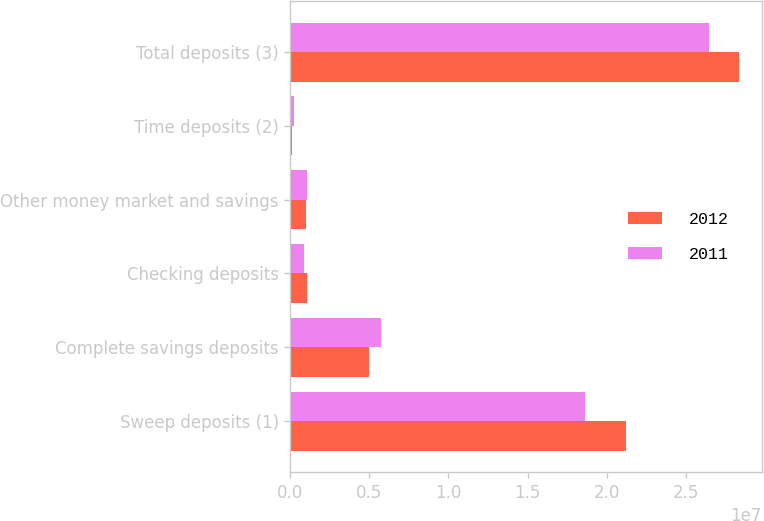<chart> <loc_0><loc_0><loc_500><loc_500><stacked_bar_chart><ecel><fcel>Sweep deposits (1)<fcel>Complete savings deposits<fcel>Checking deposits<fcel>Other money market and savings<fcel>Time deposits (2)<fcel>Total deposits (3)<nl><fcel>2012<fcel>2.12536e+07<fcel>4.98162e+06<fcel>1.05542e+06<fcel>995188<fcel>106716<fcel>2.83926e+07<nl><fcel>2011<fcel>1.8619e+07<fcel>5.72076e+06<fcel>863310<fcel>1.03325e+06<fcel>223709<fcel>2.646e+07<nl></chart> 